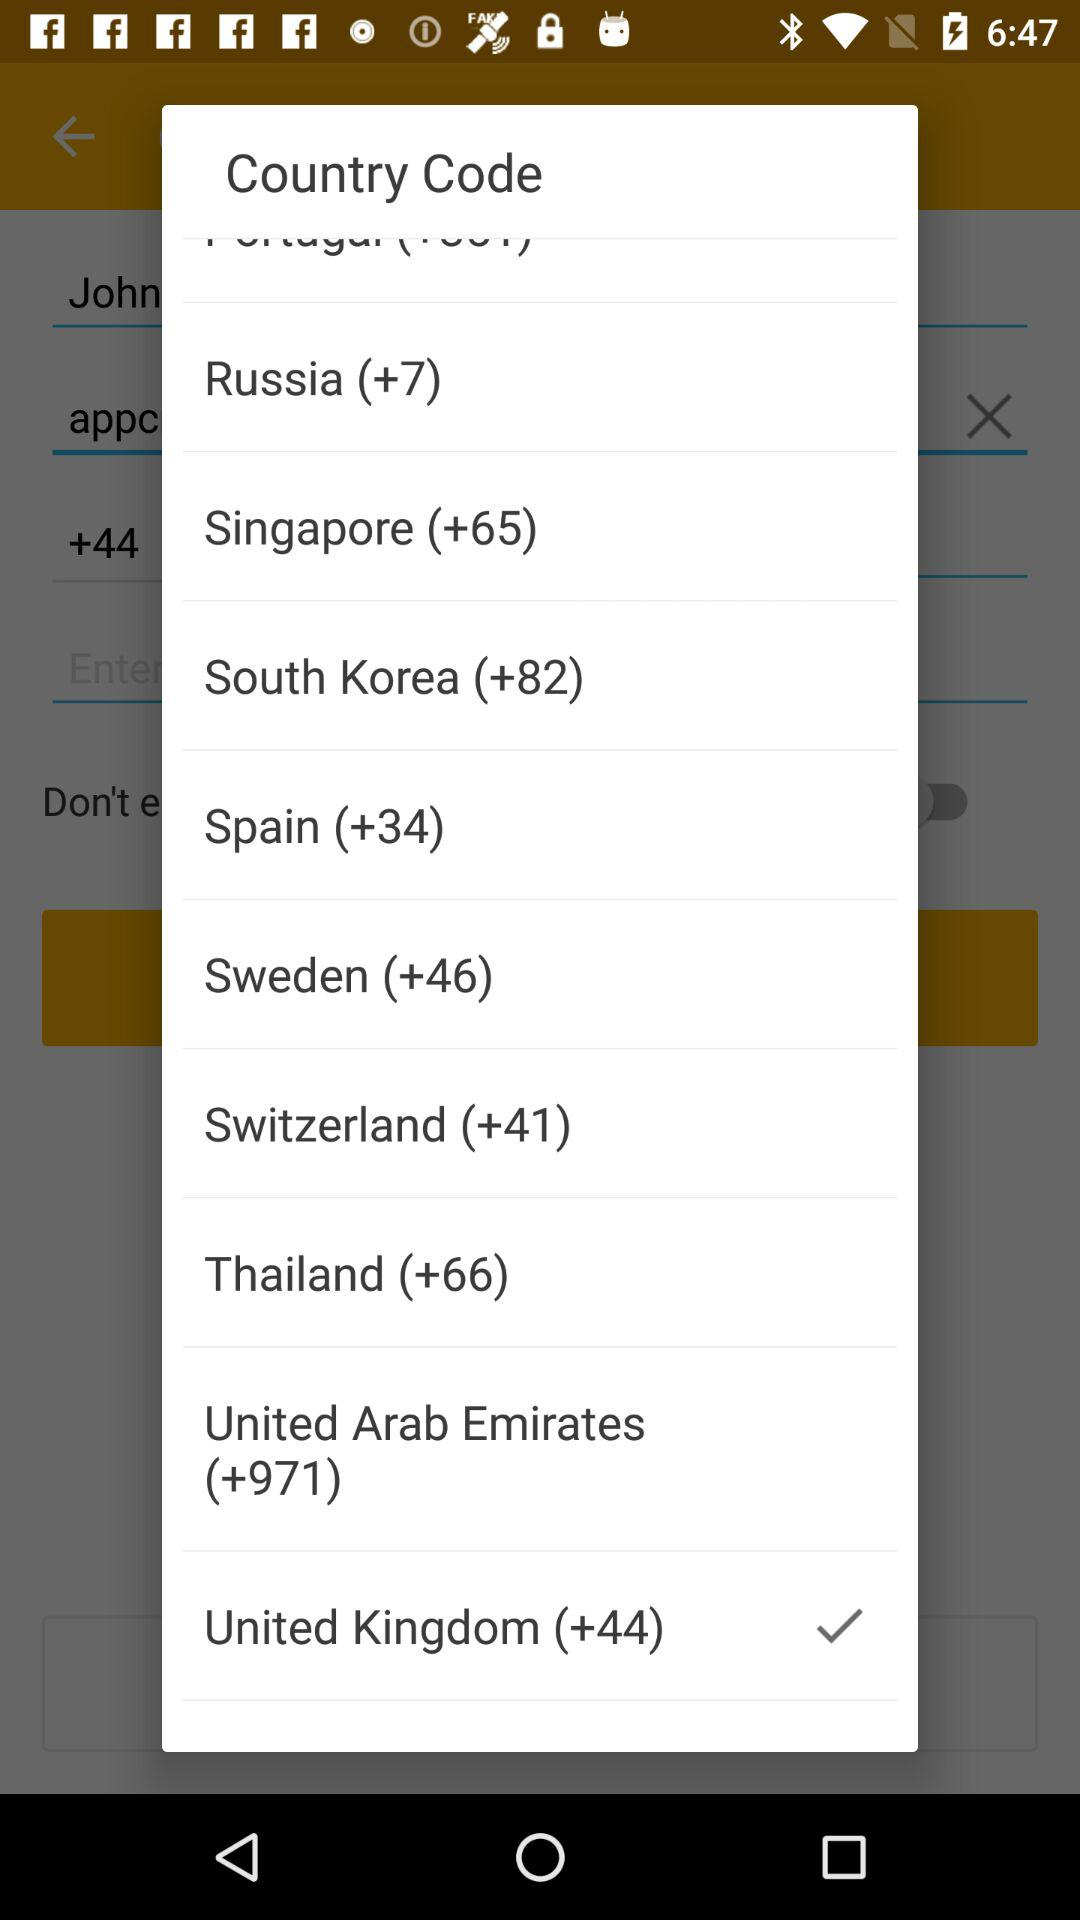What is the country code for Sweden? The country code for Sweden is +46. 